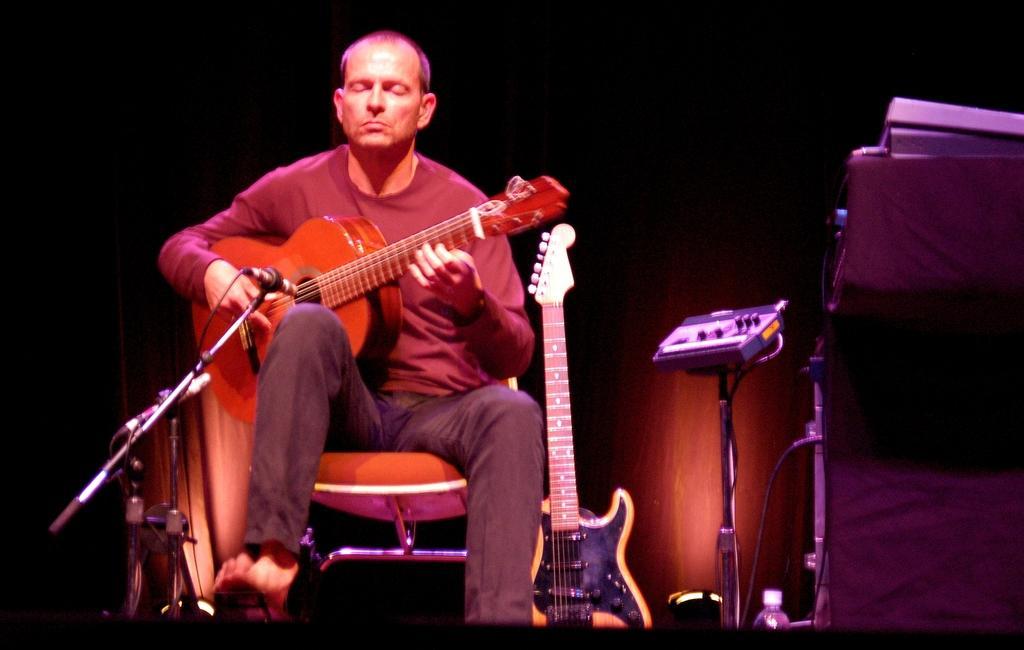Could you give a brief overview of what you see in this image? In this picture there is a man who is wearing a brown shirt and is playing a guitar. He is sitting on the chair. There is a mic in front of this man. There is another musical instrument to the right. 